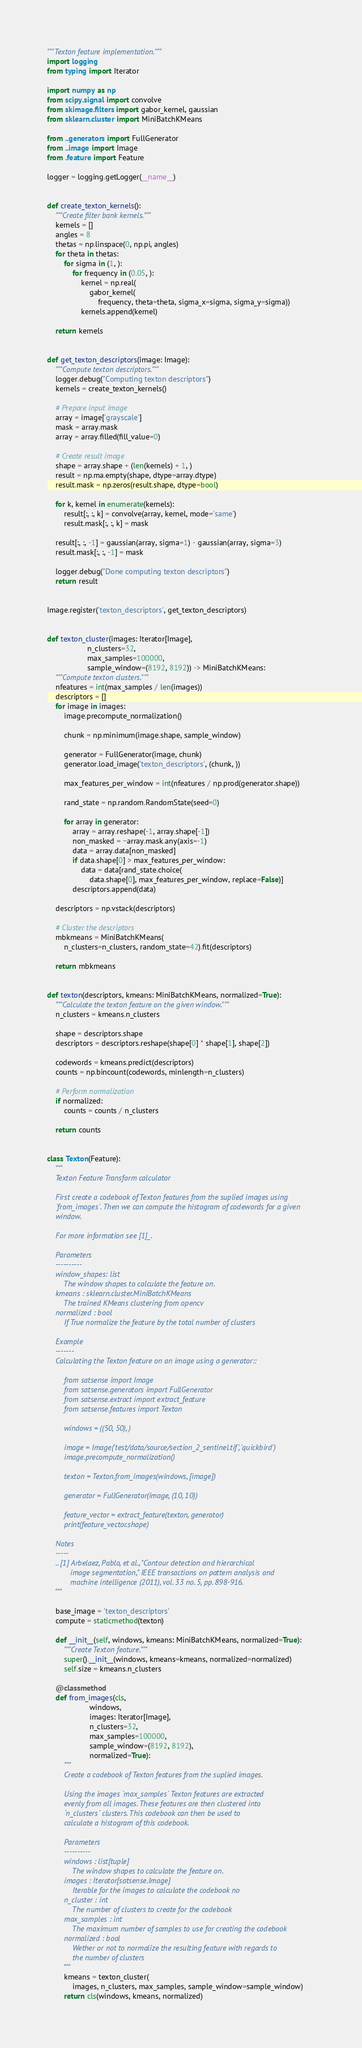<code> <loc_0><loc_0><loc_500><loc_500><_Python_>"""Texton feature implementation."""
import logging
from typing import Iterator

import numpy as np
from scipy.signal import convolve
from skimage.filters import gabor_kernel, gaussian
from sklearn.cluster import MiniBatchKMeans

from ..generators import FullGenerator
from ..image import Image
from .feature import Feature

logger = logging.getLogger(__name__)


def create_texton_kernels():
    """Create filter bank kernels."""
    kernels = []
    angles = 8
    thetas = np.linspace(0, np.pi, angles)
    for theta in thetas:
        for sigma in (1, ):
            for frequency in (0.05, ):
                kernel = np.real(
                    gabor_kernel(
                        frequency, theta=theta, sigma_x=sigma, sigma_y=sigma))
                kernels.append(kernel)

    return kernels


def get_texton_descriptors(image: Image):
    """Compute texton descriptors."""
    logger.debug("Computing texton descriptors")
    kernels = create_texton_kernels()

    # Prepare input image
    array = image['grayscale']
    mask = array.mask
    array = array.filled(fill_value=0)

    # Create result image
    shape = array.shape + (len(kernels) + 1, )
    result = np.ma.empty(shape, dtype=array.dtype)
    result.mask = np.zeros(result.shape, dtype=bool)

    for k, kernel in enumerate(kernels):
        result[:, :, k] = convolve(array, kernel, mode='same')
        result.mask[:, :, k] = mask

    result[:, :, -1] = gaussian(array, sigma=1) - gaussian(array, sigma=3)
    result.mask[:, :, -1] = mask

    logger.debug("Done computing texton descriptors")
    return result


Image.register('texton_descriptors', get_texton_descriptors)


def texton_cluster(images: Iterator[Image],
                   n_clusters=32,
                   max_samples=100000,
                   sample_window=(8192, 8192)) -> MiniBatchKMeans:
    """Compute texton clusters."""
    nfeatures = int(max_samples / len(images))
    descriptors = []
    for image in images:
        image.precompute_normalization()

        chunk = np.minimum(image.shape, sample_window)

        generator = FullGenerator(image, chunk)
        generator.load_image('texton_descriptors', (chunk, ))

        max_features_per_window = int(nfeatures / np.prod(generator.shape))

        rand_state = np.random.RandomState(seed=0)

        for array in generator:
            array = array.reshape(-1, array.shape[-1])
            non_masked = ~array.mask.any(axis=-1)
            data = array.data[non_masked]
            if data.shape[0] > max_features_per_window:
                data = data[rand_state.choice(
                    data.shape[0], max_features_per_window, replace=False)]
            descriptors.append(data)

    descriptors = np.vstack(descriptors)

    # Cluster the descriptors
    mbkmeans = MiniBatchKMeans(
        n_clusters=n_clusters, random_state=42).fit(descriptors)

    return mbkmeans


def texton(descriptors, kmeans: MiniBatchKMeans, normalized=True):
    """Calculate the texton feature on the given window."""
    n_clusters = kmeans.n_clusters

    shape = descriptors.shape
    descriptors = descriptors.reshape(shape[0] * shape[1], shape[2])

    codewords = kmeans.predict(descriptors)
    counts = np.bincount(codewords, minlength=n_clusters)

    # Perform normalization
    if normalized:
        counts = counts / n_clusters

    return counts


class Texton(Feature):
    """
    Texton Feature Transform calculator

    First create a codebook of Texton features from the suplied images using
    `from_images`. Then we can compute the histogram of codewords for a given
    window.

    For more information see [1]_.

    Parameters
    ----------
    window_shapes: list
        The window shapes to calculate the feature on.
    kmeans : sklearn.cluster.MiniBatchKMeans
        The trained KMeans clustering from opencv
    normalized : bool
        If True normalize the feature by the total number of clusters

    Example
    -------
    Calculating the Texton feature on an image using a generator::

        from satsense import Image
        from satsense.generators import FullGenerator
        from satsense.extract import extract_feature
        from satsense.features import Texton

        windows = ((50, 50), )

        image = Image('test/data/source/section_2_sentinel.tif', 'quickbird')
        image.precompute_normalization()

        texton = Texton.from_images(windows, [image])

        generator = FullGenerator(image, (10, 10))

        feature_vector = extract_feature(texton, generator)
        print(feature_vector.shape)

    Notes
    -----
    .. [1] Arbelaez, Pablo, et al., "Contour detection and hierarchical
           image segmentation," IEEE transactions on pattern analysis and
           machine intelligence (2011), vol. 33 no. 5, pp. 898-916.
    """

    base_image = 'texton_descriptors'
    compute = staticmethod(texton)

    def __init__(self, windows, kmeans: MiniBatchKMeans, normalized=True):
        """Create Texton feature."""
        super().__init__(windows, kmeans=kmeans, normalized=normalized)
        self.size = kmeans.n_clusters

    @classmethod
    def from_images(cls,
                    windows,
                    images: Iterator[Image],
                    n_clusters=32,
                    max_samples=100000,
                    sample_window=(8192, 8192),
                    normalized=True):
        """
        Create a codebook of Texton features from the suplied images.

        Using the images `max_samples` Texton features are extracted
        evenly from all images. These features are then clustered into
        `n_clusters` clusters. This codebook can then be used to
        calculate a histogram of this codebook.

        Parameters
        ----------
        windows : list[tuple]
            The window shapes to calculate the feature on.
        images : Iterator[satsense.Image]
            Iterable for the images to calculate the codebook no
        n_cluster : int
            The number of clusters to create for the codebook
        max_samples : int
            The maximum number of samples to use for creating the codebook
        normalized : bool
            Wether or not to normalize the resulting feature with regards to
            the number of clusters
        """
        kmeans = texton_cluster(
            images, n_clusters, max_samples, sample_window=sample_window)
        return cls(windows, kmeans, normalized)
</code> 